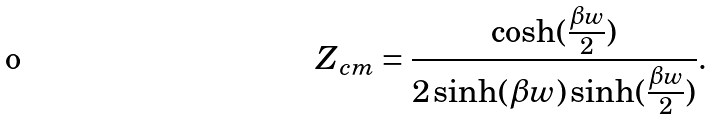<formula> <loc_0><loc_0><loc_500><loc_500>Z _ { c m } = \frac { \cosh ( \frac { \beta w } { 2 } ) } { 2 \sinh ( \beta w ) \sinh ( \frac { \beta w } { 2 } ) } .</formula> 